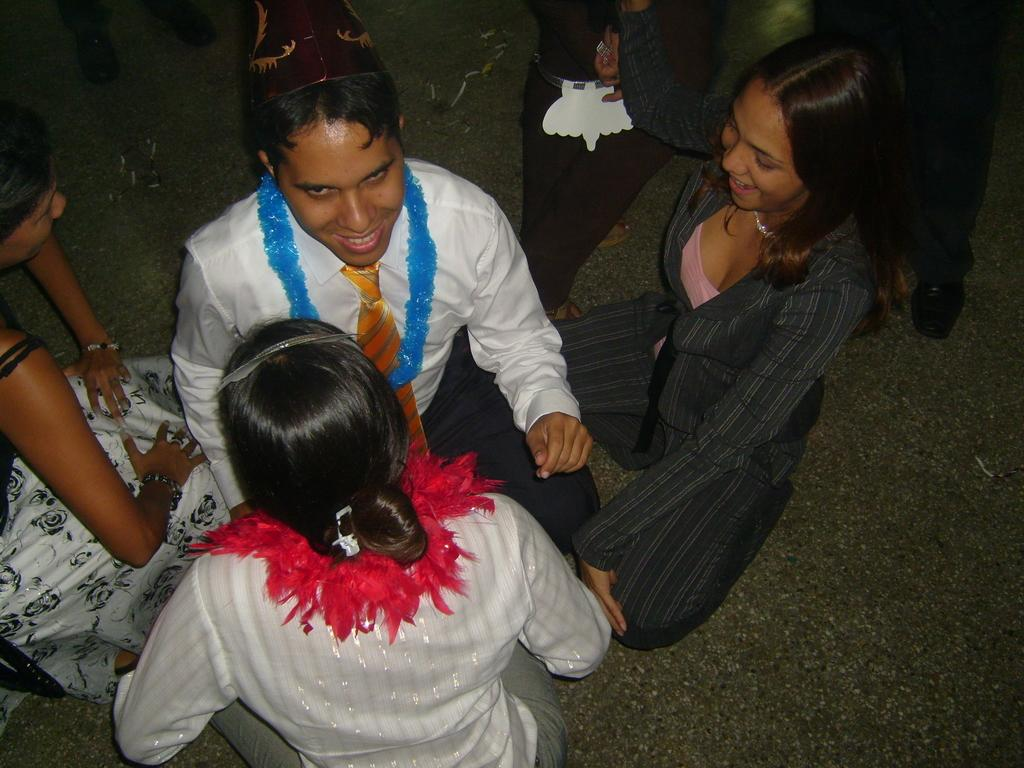What is the main subject of the image? The main subject of the image is a group of people. Can you describe the man in the middle of the image? The man in the middle of the image is wearing a white dress. What is the man's facial expression in the image? The man is smiling in the image. What type of trousers is the man wearing under his white dress in the image? The man is not wearing trousers under his white dress in the image; he is wearing a dress. What kind of cloth is used to make the man's bead in the image? There is no bead present in the image. 